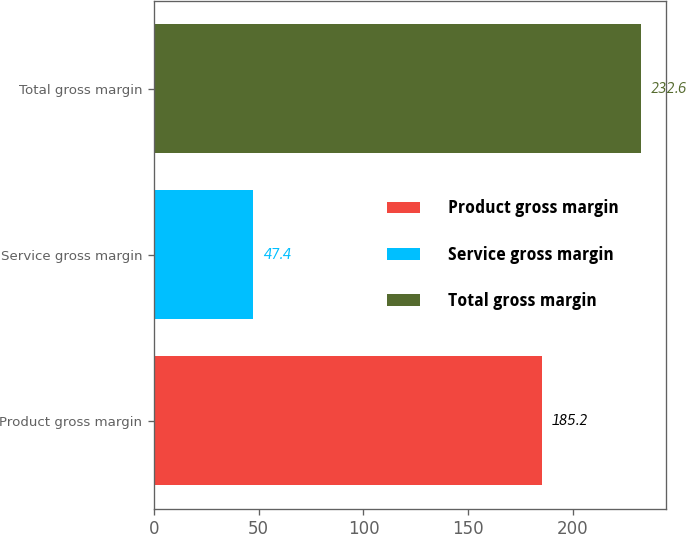<chart> <loc_0><loc_0><loc_500><loc_500><bar_chart><fcel>Product gross margin<fcel>Service gross margin<fcel>Total gross margin<nl><fcel>185.2<fcel>47.4<fcel>232.6<nl></chart> 